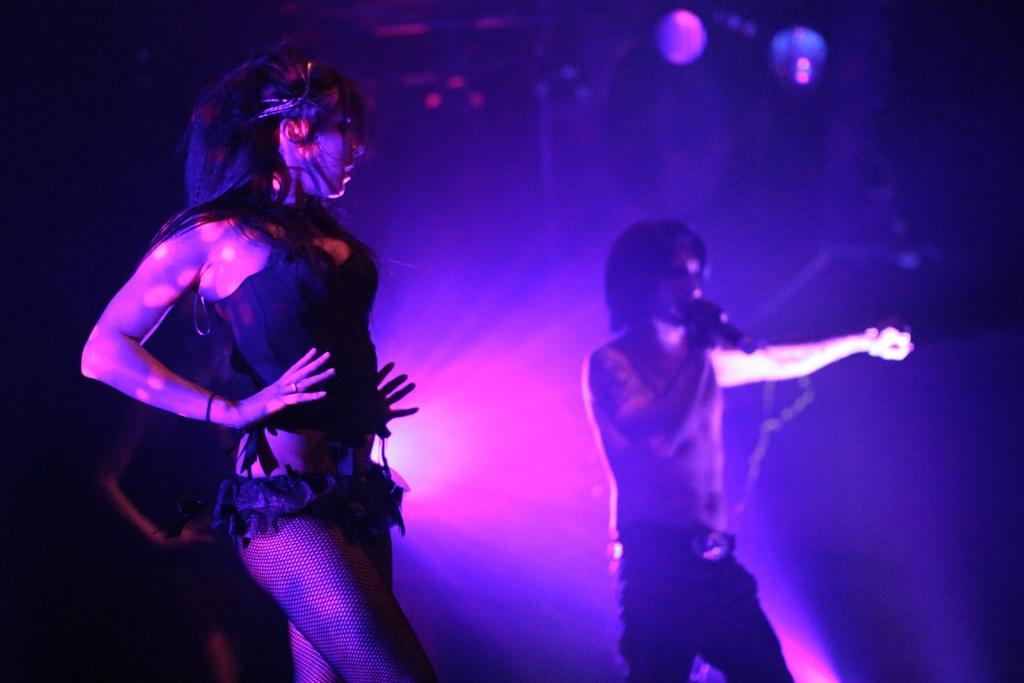What are the people on the left side of the image doing? The persons on the left side of the image are standing and dancing. How many people are visible on the right side of the image? There is one person visible on the right side of the image. What is the person on the right side holding? The person on the right side is holding a microphone. Can you tell me how many eggs are being cracked on the left side of the image? There are no eggs present in the image; the people on the left side are standing and dancing. What type of page is being turned by the person on the right side of the image? There is no page present in the image; the person on the right side is holding a microphone. 